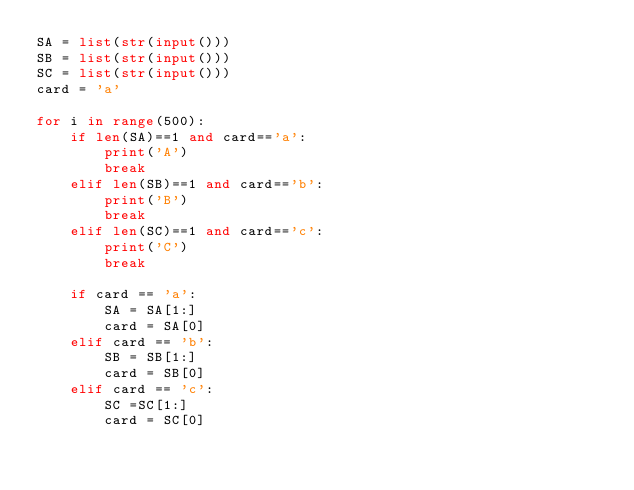Convert code to text. <code><loc_0><loc_0><loc_500><loc_500><_Python_>SA = list(str(input())) 
SB = list(str(input())) 
SC = list(str(input())) 
card = 'a'

for i in range(500):
    if len(SA)==1 and card=='a':
        print('A')
        break
    elif len(SB)==1 and card=='b':
        print('B')
        break
    elif len(SC)==1 and card=='c':
        print('C')
        break
        
    if card == 'a':
        SA = SA[1:]
        card = SA[0]
    elif card == 'b':
        SB = SB[1:]
        card = SB[0]
    elif card == 'c':
        SC =SC[1:]
        card = SC[0]</code> 